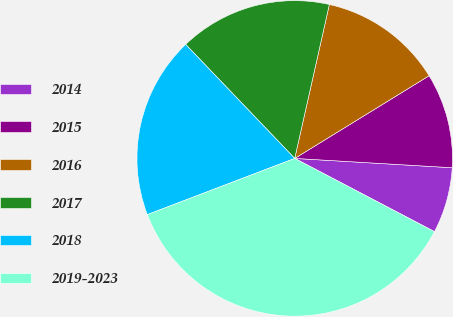Convert chart to OTSL. <chart><loc_0><loc_0><loc_500><loc_500><pie_chart><fcel>2014<fcel>2015<fcel>2016<fcel>2017<fcel>2018<fcel>2019-2023<nl><fcel>6.74%<fcel>9.72%<fcel>12.7%<fcel>15.67%<fcel>18.65%<fcel>36.52%<nl></chart> 